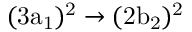<formula> <loc_0><loc_0><loc_500><loc_500>( 3 a _ { 1 } ) ^ { 2 } \rightarrow ( 2 b _ { 2 } ) ^ { 2 }</formula> 